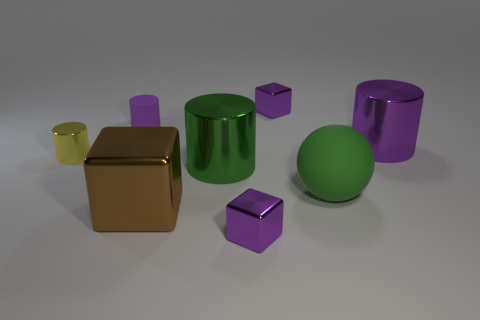There is a metallic cylinder that is the same color as the matte cylinder; what size is it?
Your response must be concise. Large. Is there any other thing that is made of the same material as the big purple thing?
Provide a short and direct response. Yes. Does the green metal thing have the same shape as the tiny rubber object to the left of the large purple cylinder?
Provide a succinct answer. Yes. What number of other things are there of the same size as the matte ball?
Ensure brevity in your answer.  3. What number of cyan objects are large shiny objects or small metal cylinders?
Your response must be concise. 0. How many things are both in front of the tiny yellow object and left of the big ball?
Offer a terse response. 3. What material is the purple cube in front of the metallic block right of the purple thing that is in front of the green metallic object?
Your answer should be very brief. Metal. What number of large objects are the same material as the green cylinder?
Your answer should be compact. 2. There is a large metallic thing that is the same color as the matte cylinder; what shape is it?
Make the answer very short. Cylinder. There is a purple shiny thing that is the same size as the sphere; what shape is it?
Provide a short and direct response. Cylinder. 